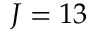<formula> <loc_0><loc_0><loc_500><loc_500>J = 1 3</formula> 